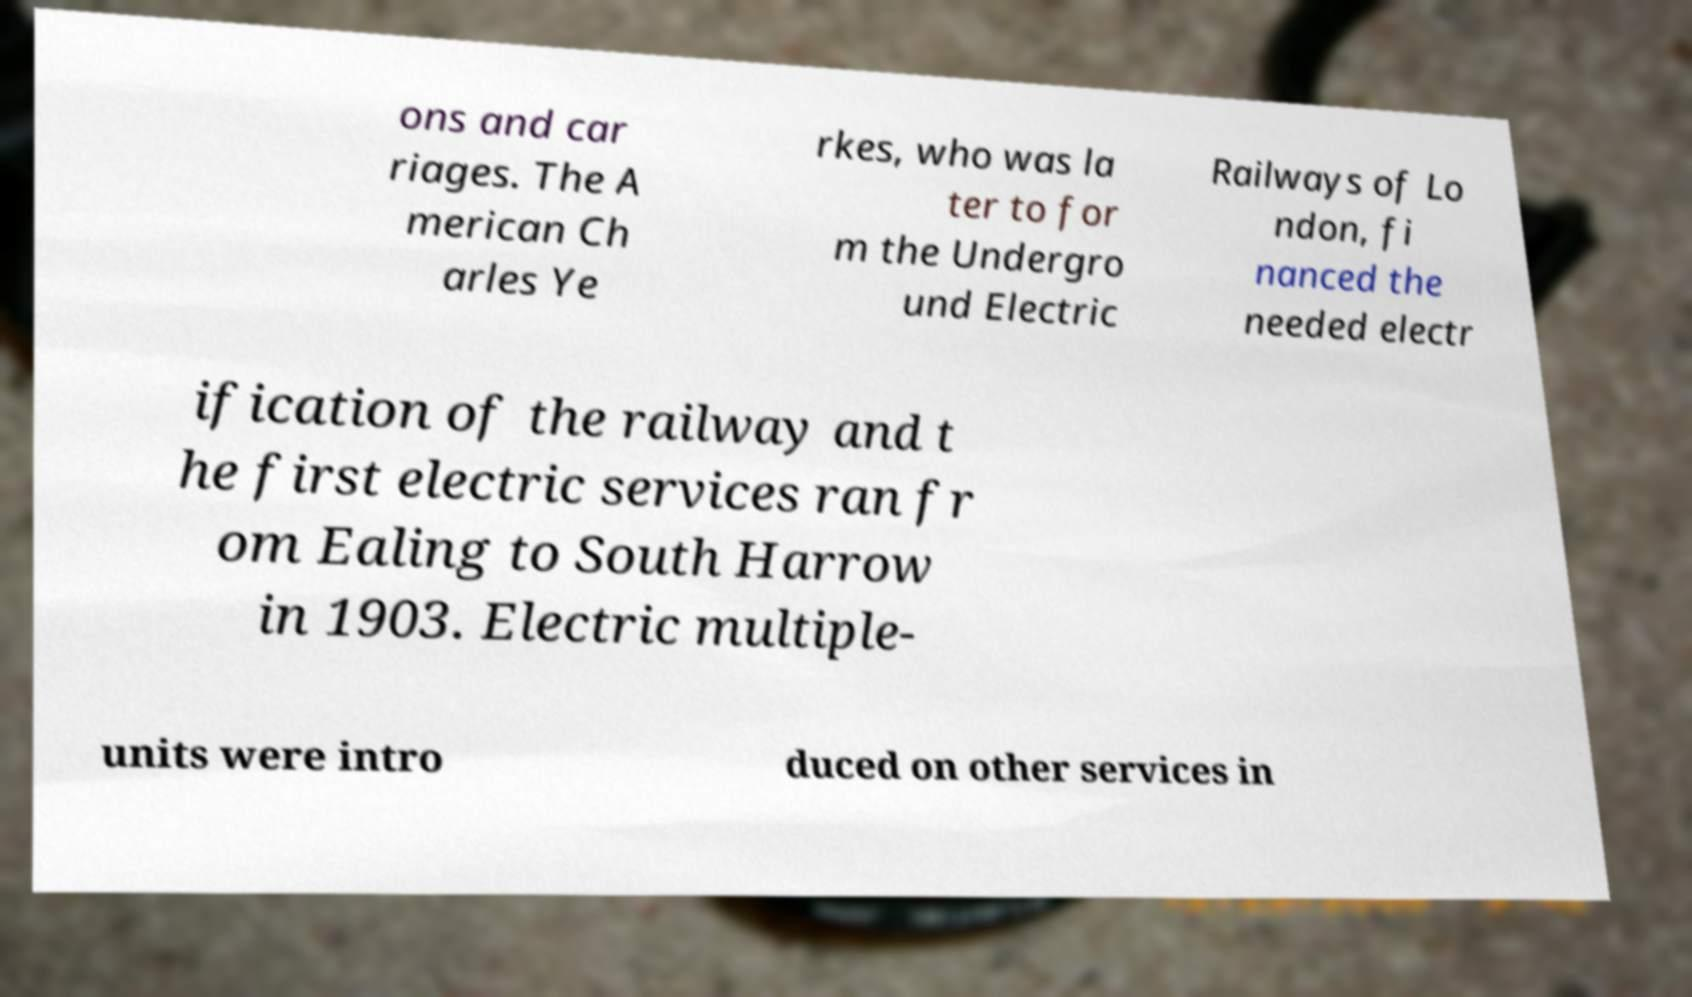Can you read and provide the text displayed in the image?This photo seems to have some interesting text. Can you extract and type it out for me? ons and car riages. The A merican Ch arles Ye rkes, who was la ter to for m the Undergro und Electric Railways of Lo ndon, fi nanced the needed electr ification of the railway and t he first electric services ran fr om Ealing to South Harrow in 1903. Electric multiple- units were intro duced on other services in 